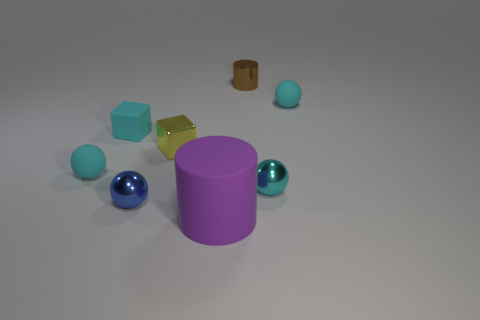What number of blue shiny balls are the same size as the yellow metal object?
Keep it short and to the point. 1. There is a tiny rubber sphere that is left of the tiny matte ball that is to the right of the small cylinder; what color is it?
Give a very brief answer. Cyan. Is there a metal object of the same color as the matte cube?
Offer a very short reply. Yes. What color is the other block that is the same size as the yellow block?
Give a very brief answer. Cyan. Is the material of the brown thing that is on the right side of the small cyan cube the same as the yellow cube?
Ensure brevity in your answer.  Yes. Are there any cyan rubber things that are in front of the ball that is behind the small cyan sphere that is left of the small yellow metallic object?
Provide a short and direct response. Yes. There is a metallic thing on the left side of the tiny yellow metallic cube; is it the same shape as the cyan shiny object?
Provide a succinct answer. Yes. There is a tiny metal thing that is right of the cylinder on the right side of the large thing; what is its shape?
Provide a succinct answer. Sphere. There is a cylinder in front of the matte ball on the right side of the small object that is in front of the small cyan metallic object; how big is it?
Give a very brief answer. Large. What is the color of the other small shiny thing that is the same shape as the tiny blue shiny thing?
Offer a terse response. Cyan. 